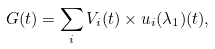<formula> <loc_0><loc_0><loc_500><loc_500>G ( t ) = \sum _ { i } V _ { i } ( t ) \times u _ { i } ( \lambda _ { 1 } ) ( t ) ,</formula> 